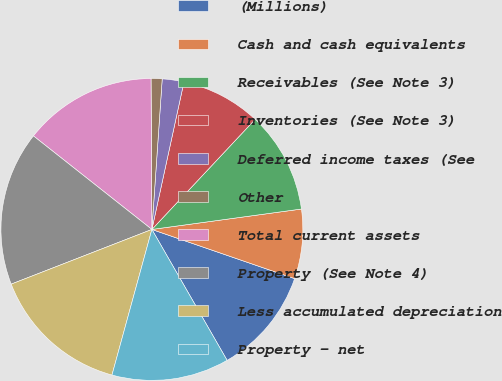Convert chart. <chart><loc_0><loc_0><loc_500><loc_500><pie_chart><fcel>(Millions)<fcel>Cash and cash equivalents<fcel>Receivables (See Note 3)<fcel>Inventories (See Note 3)<fcel>Deferred income taxes (See<fcel>Other<fcel>Total current assets<fcel>Property (See Note 4)<fcel>Less accumulated depreciation<fcel>Property - net<nl><fcel>11.42%<fcel>7.44%<fcel>10.85%<fcel>8.58%<fcel>2.32%<fcel>1.18%<fcel>14.27%<fcel>16.54%<fcel>14.84%<fcel>12.56%<nl></chart> 